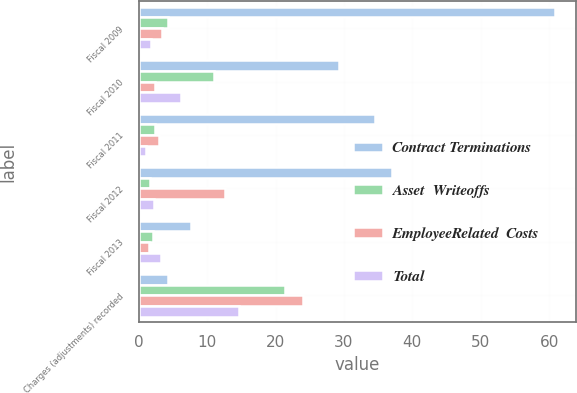Convert chart. <chart><loc_0><loc_0><loc_500><loc_500><stacked_bar_chart><ecel><fcel>Fiscal 2009<fcel>Fiscal 2010<fcel>Fiscal 2011<fcel>Fiscal 2012<fcel>Fiscal 2013<fcel>Charges (adjustments) recorded<nl><fcel>Contract Terminations<fcel>60.9<fcel>29.3<fcel>34.6<fcel>37.1<fcel>7.7<fcel>4.2<nl><fcel>Asset  Writeoffs<fcel>4.2<fcel>11<fcel>2.4<fcel>1.7<fcel>2.1<fcel>21.4<nl><fcel>EmployeeRelated  Costs<fcel>3.4<fcel>2.3<fcel>3<fcel>12.6<fcel>1.5<fcel>24<nl><fcel>Total<fcel>1.8<fcel>6.2<fcel>1.1<fcel>2.2<fcel>3.3<fcel>14.6<nl></chart> 